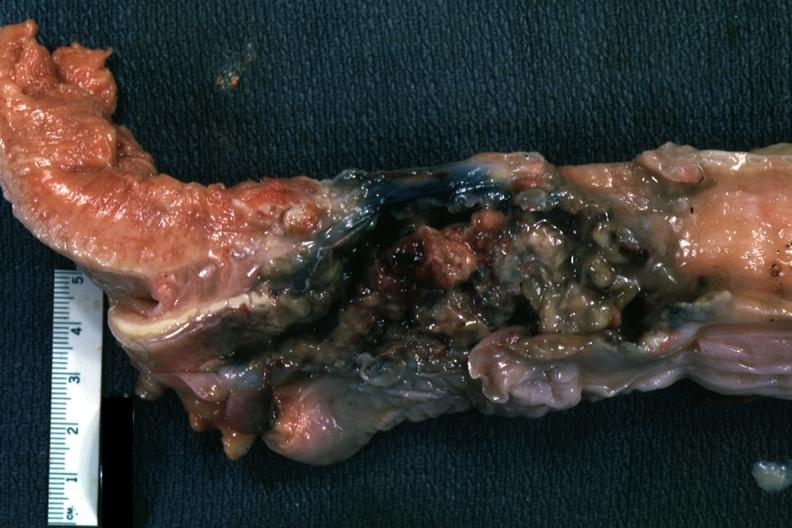what is present?
Answer the question using a single word or phrase. Carcinoma 